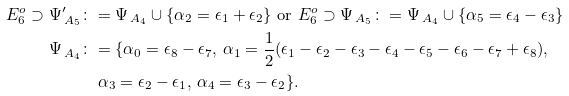Convert formula to latex. <formula><loc_0><loc_0><loc_500><loc_500>E _ { 6 } ^ { o } \supset \Psi _ { \, A _ { 5 } } ^ { \prime } & \colon = \Psi _ { \, A _ { 4 } } \cup \{ \alpha _ { 2 } = \epsilon _ { 1 } + \epsilon _ { 2 } \} \text { or } E _ { 6 } ^ { o } \supset \Psi _ { \, A _ { 5 } } \colon = \Psi _ { \, A _ { 4 } } \cup \{ \alpha _ { 5 } = \epsilon _ { 4 } - \epsilon _ { 3 } \} \\ \Psi _ { \, A _ { 4 } } & \colon = \{ \alpha _ { 0 } = \epsilon _ { 8 } - \epsilon _ { 7 } , \, \alpha _ { 1 } = \frac { 1 } { 2 } ( \epsilon _ { 1 } - \epsilon _ { 2 } - \epsilon _ { 3 } - \epsilon _ { 4 } - \epsilon _ { 5 } - \epsilon _ { 6 } - \epsilon _ { 7 } + \epsilon _ { 8 } ) , \\ & \quad \alpha _ { 3 } = \epsilon _ { 2 } - \epsilon _ { 1 } , \, \alpha _ { 4 } = \epsilon _ { 3 } - \epsilon _ { 2 } \} .</formula> 